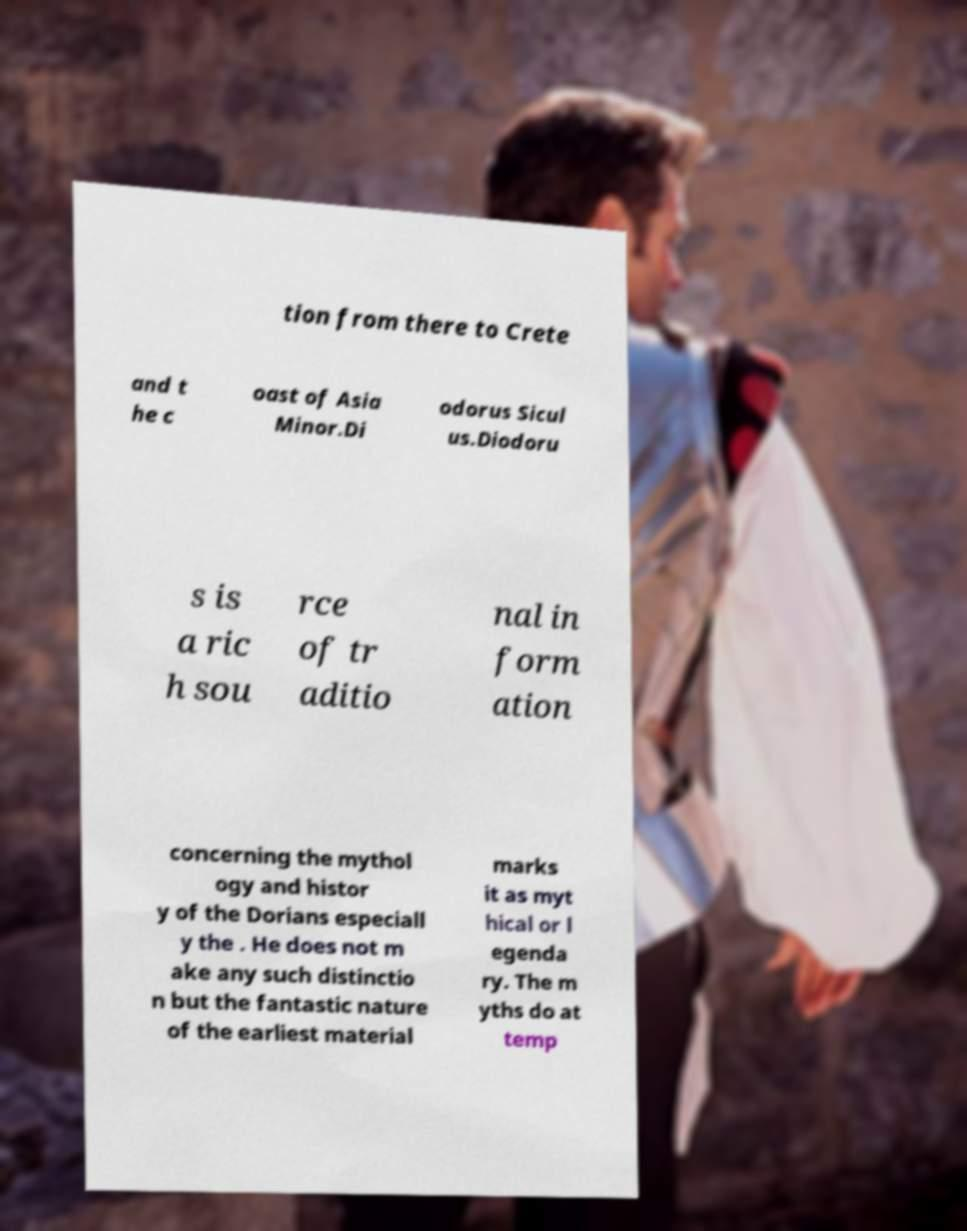What messages or text are displayed in this image? I need them in a readable, typed format. tion from there to Crete and t he c oast of Asia Minor.Di odorus Sicul us.Diodoru s is a ric h sou rce of tr aditio nal in form ation concerning the mythol ogy and histor y of the Dorians especiall y the . He does not m ake any such distinctio n but the fantastic nature of the earliest material marks it as myt hical or l egenda ry. The m yths do at temp 